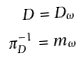<formula> <loc_0><loc_0><loc_500><loc_500>D = D _ { \omega } \\ \pi _ { D } ^ { - 1 } = m _ { \omega }</formula> 